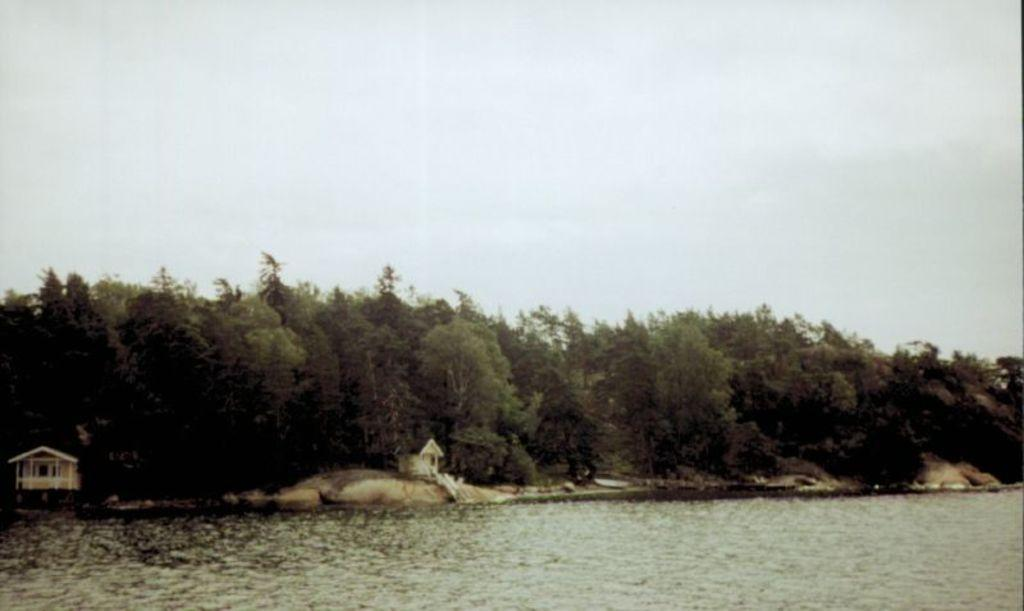What is at the bottom of the image? There is water at the bottom of the image. What structures can be seen on the ground in the image? There are houses on the ground in the image. What type of vegetation is visible in the background of the image? There are trees in the background of the image. What can be seen in the sky in the background of the image? There are clouds in the sky in the background of the image. What type of religion is practiced by the people in the image? There is no information about religion in the image, as it only shows water, houses, trees, and clouds. How far away is the nearest town from the location depicted in the image? The distance to the nearest town cannot be determined from the image, as it only shows water, houses, trees, and clouds. 